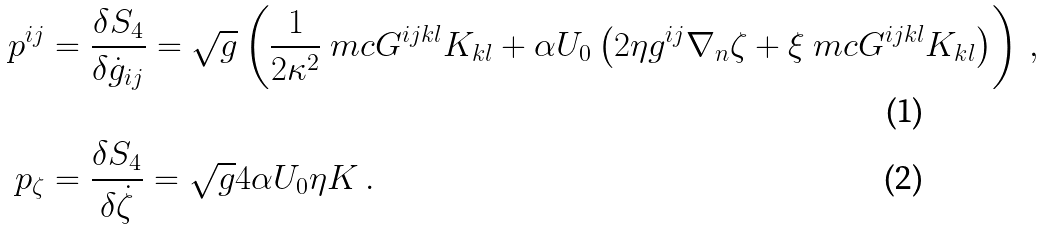<formula> <loc_0><loc_0><loc_500><loc_500>p ^ { i j } & = \frac { \delta S _ { 4 } } { \delta \dot { g } _ { i j } } = \sqrt { g } \left ( \frac { 1 } { 2 \kappa ^ { 2 } } \ m c { G } ^ { i j k l } K _ { k l } + \alpha U _ { 0 } \left ( 2 \eta g ^ { i j } \nabla _ { n } \zeta + \xi \ m c { G } ^ { i j k l } K _ { k l } \right ) \right ) \, , \\ p _ { \zeta } & = \frac { \delta S _ { 4 } } { \delta \dot { \zeta } } = \sqrt { g } 4 \alpha U _ { 0 } \eta K \, .</formula> 